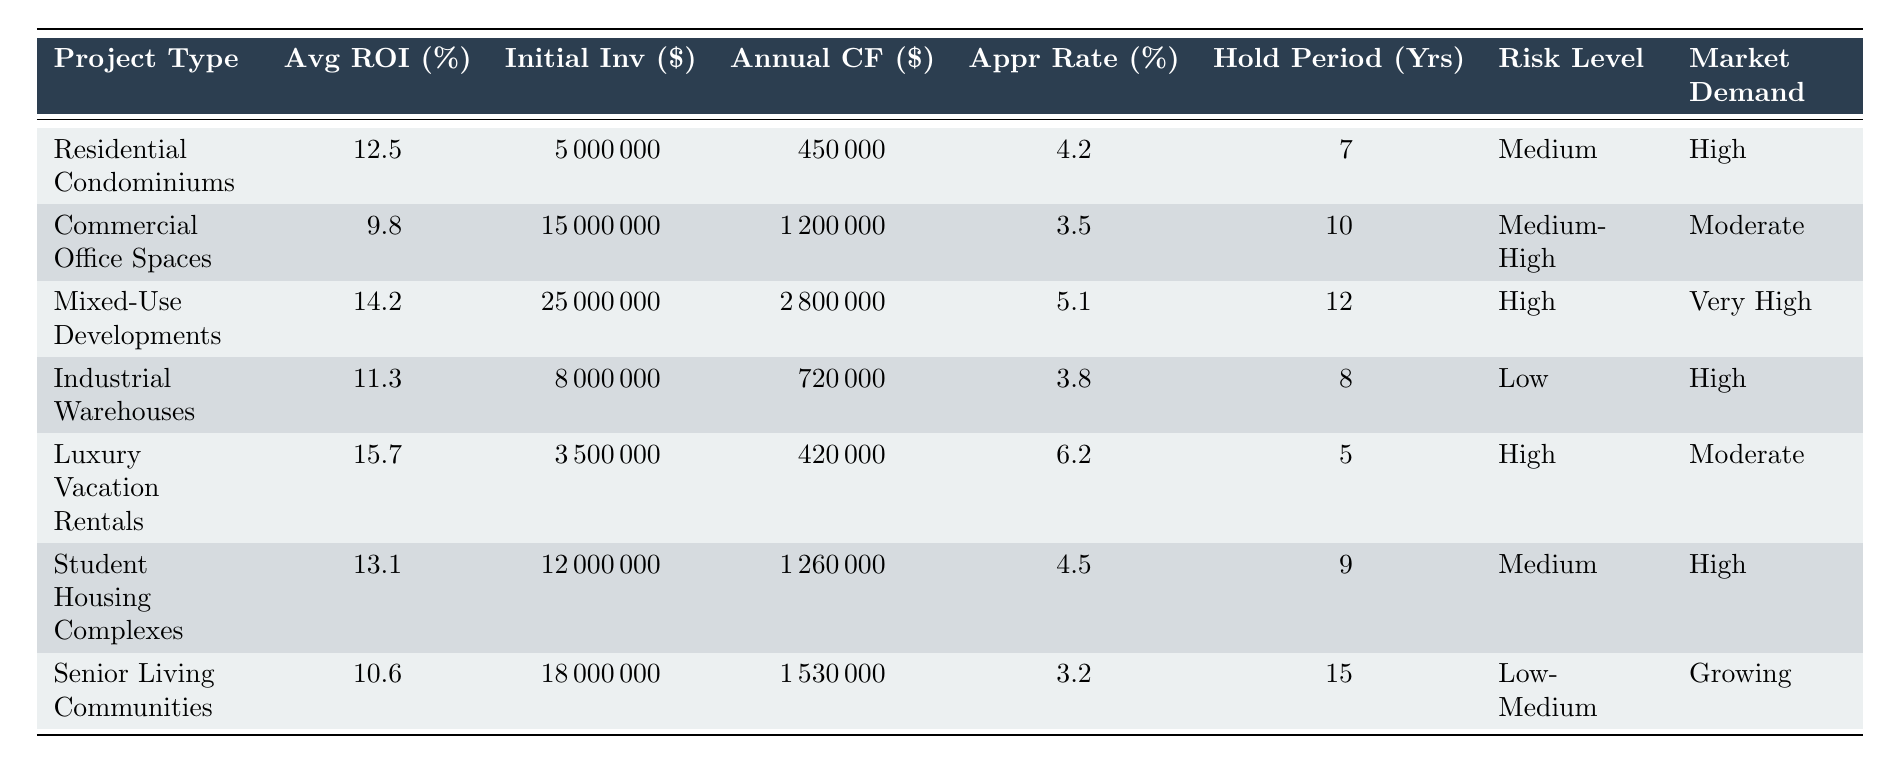What is the average ROI for Residential Condominiums? The table shows that the average ROI for Residential Condominiums is listed directly under the "Average ROI (%)" column for that project type, which is 12.5%.
Answer: 12.5% What is the initial investment for Mixed-Use Developments? The initial investment for Mixed-Use Developments can be found in the corresponding row under the "Initial Investment ($)" column which indicates it is 25000000 dollars.
Answer: 25000000 Which project type has the highest annual cash flow? By comparing the "Annual Cash Flow ($)" values in the table, Mixed-Use Developments has the highest annual cash flow of 2800000 dollars.
Answer: Mixed-Use Developments Is the appreciation rate for Senior Living Communities higher than that for Commercial Office Spaces? The appreciation rate for Senior Living Communities is 3.2% and for Commercial Office Spaces, it is 3.5%. Since 3.2% is less than 3.5%, the statement is false.
Answer: No What is the total average ROI for both Industrial Warehouses and Luxury Vacation Rentals? The average ROI for Industrial Warehouses is 11.3% and for Luxury Vacation Rentals is 15.7%. Adding these together gives 11.3% + 15.7% = 27%. To find the average, you divide by 2, yielding 27% / 2 = 13.5%.
Answer: 13.5% Which project types have a risk level of "Medium" or lower? By reviewing the "Risk Level" column, the project types with "Medium" or lower risk levels include Residential Condominiums, Industrial Warehouses, and Senior Living Communities.
Answer: 3 types How many years is the holding period for the project type that has the lowest average ROI? The project type with the lowest average ROI is Commercial Office Spaces at 9.8%. The holding period for this project is 10 years, as noted in the "Holding Period (Years)" column.
Answer: 10 What is the difference in annual cash flow between Mixed-Use Developments and Luxury Vacation Rentals? The annual cash flow for Mixed-Use Developments is 2800000 dollars, and for Luxury Vacation Rentals, it is 420000 dollars. The difference is 2800000 - 420000 = 2380000 dollars.
Answer: 2380000 Is the market demand for Student Housing Complexes high? The market demand listed for Student Housing Complexes in the table is "High", confirming the statement is true.
Answer: Yes 